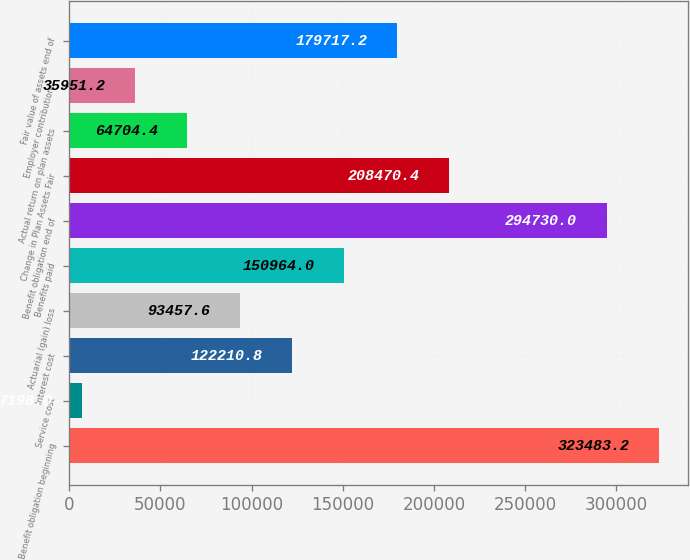Convert chart to OTSL. <chart><loc_0><loc_0><loc_500><loc_500><bar_chart><fcel>Benefit obligation beginning<fcel>Service cost<fcel>Interest cost<fcel>Actuarial (gain) loss<fcel>Benefits paid<fcel>Benefit obligation end of<fcel>Change in Plan Assets Fair<fcel>Actual return on plan assets<fcel>Employer contributions<fcel>Fair value of assets end of<nl><fcel>323483<fcel>7198<fcel>122211<fcel>93457.6<fcel>150964<fcel>294730<fcel>208470<fcel>64704.4<fcel>35951.2<fcel>179717<nl></chart> 